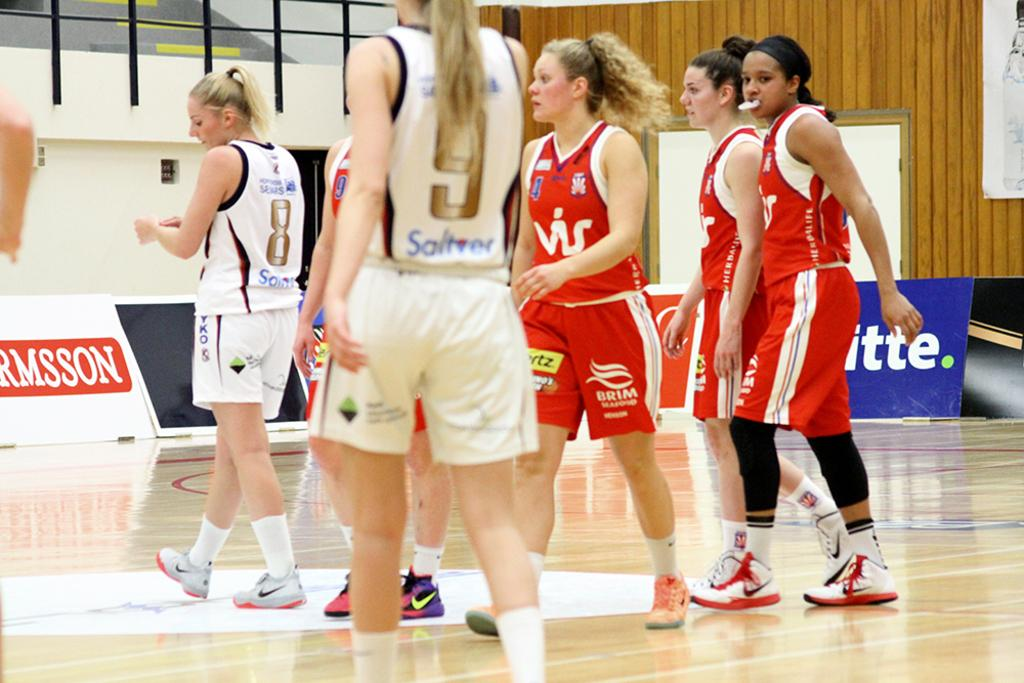<image>
Give a short and clear explanation of the subsequent image. Baeball player wearing red and shorts that say "BRIM" is walking on the court. 